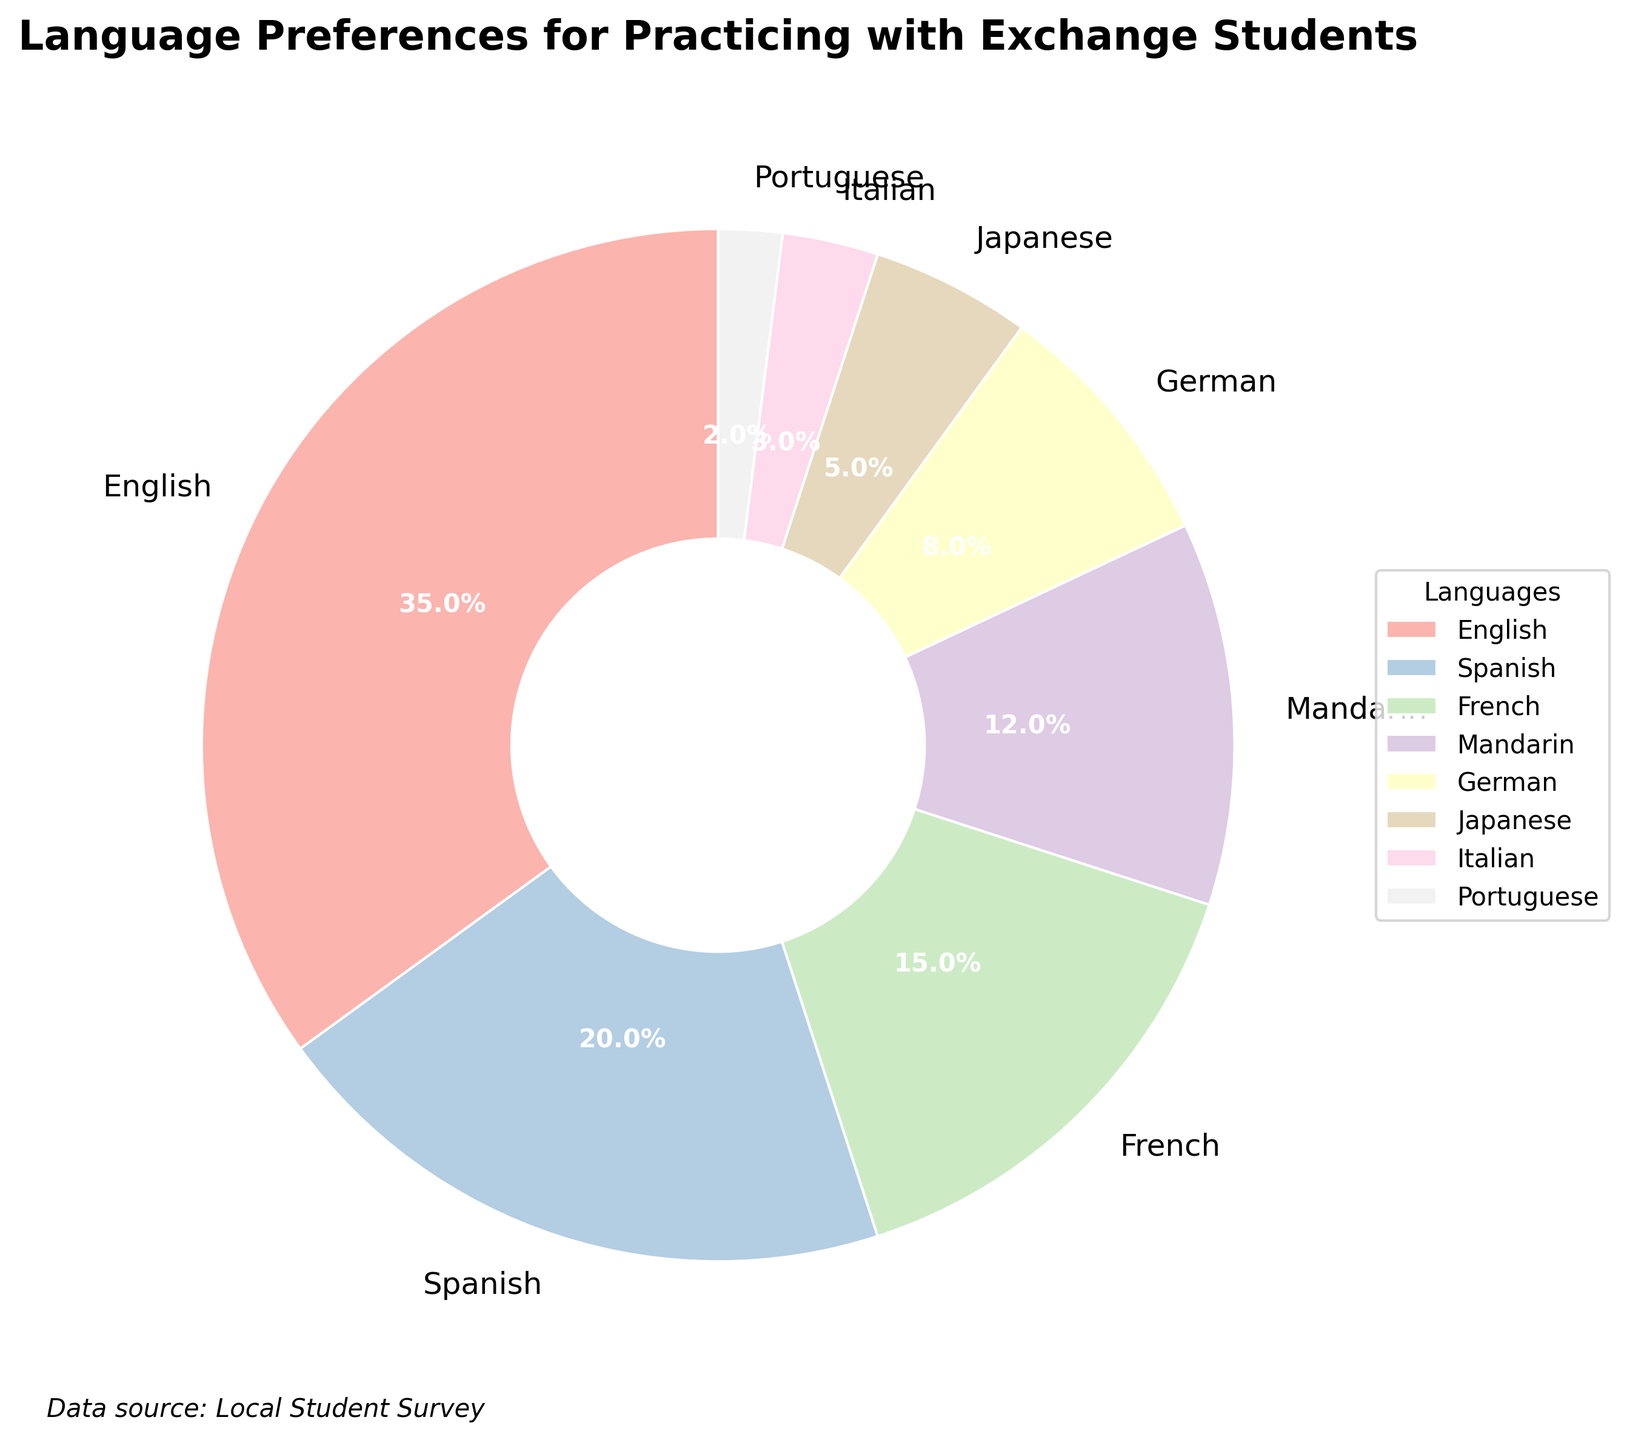What percentage of students prefer French? The chart segment labeled "French" shows the percentage.
Answer: 15% Which language has the highest percentage of student preferences? The largest segment in the chart is labeled "English".
Answer: English Calculate the total percentage of students who prefer Japanese and Italian combined. Add the percentages from the "Japanese" and "Italian" segments: 5% + 3%.
Answer: 8% Which is preferred more, Mandarin or German? Compare the percentages of the "Mandarin" and "German" segments. Mandarin is 12% and German is 8%.
Answer: Mandarin Out of Spanish, French, and Mandarin, which language has the lowest preference? Compare the segments for Spanish (20%), French (15%), and Mandarin (12%).
Answer: Mandarin How much larger is the percentage of students preferring English compared to those preferring Portuguese? Subtract the percentage for Portuguese from the percentage for English: 35% - 2%.
Answer: 33% What percentage of students prefer either Spanish or German? Add the percentages for Spanish and German: 20% + 8%.
Answer: 28% List the top three most preferred languages among local students. Look at the chart and identify the top three largest segments: English (35%), Spanish (20%), French (15%).
Answer: English, Spanish, French 